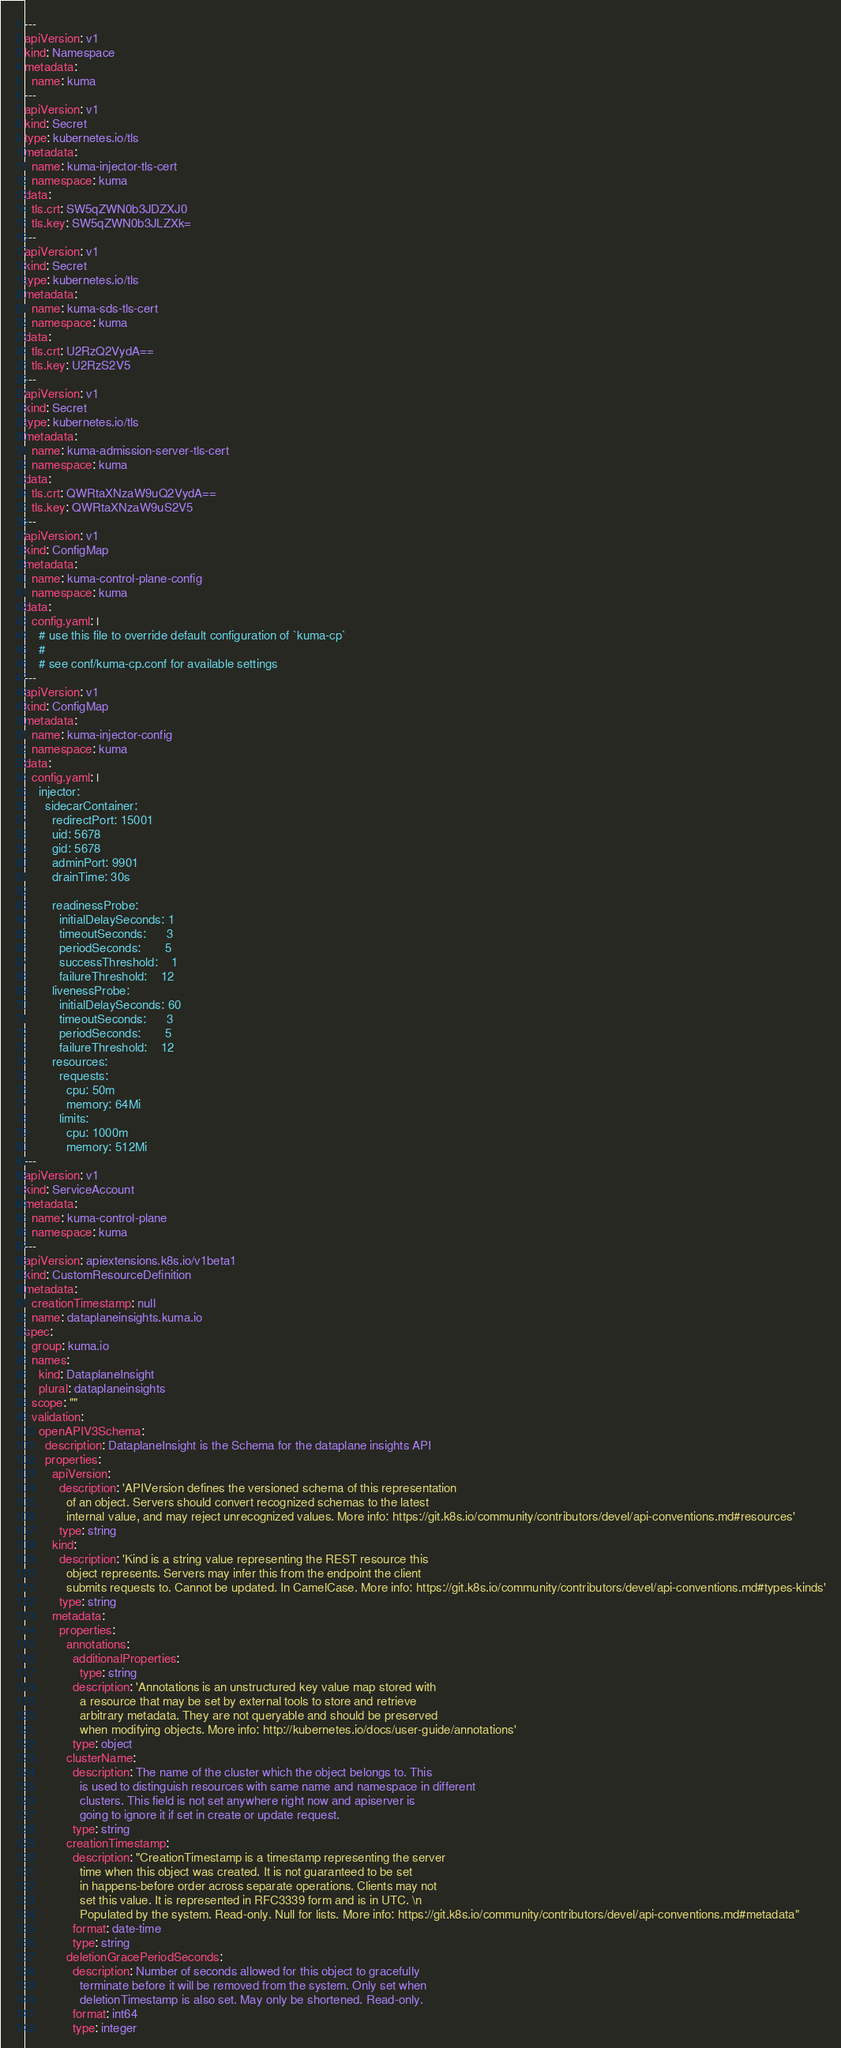Convert code to text. <code><loc_0><loc_0><loc_500><loc_500><_YAML_>---
apiVersion: v1
kind: Namespace
metadata:
  name: kuma
---
apiVersion: v1
kind: Secret
type: kubernetes.io/tls
metadata:
  name: kuma-injector-tls-cert
  namespace: kuma
data:
  tls.crt: SW5qZWN0b3JDZXJ0
  tls.key: SW5qZWN0b3JLZXk=
---
apiVersion: v1
kind: Secret
type: kubernetes.io/tls
metadata:
  name: kuma-sds-tls-cert
  namespace: kuma
data:
  tls.crt: U2RzQ2VydA==
  tls.key: U2RzS2V5
---
apiVersion: v1
kind: Secret
type: kubernetes.io/tls
metadata:
  name: kuma-admission-server-tls-cert
  namespace: kuma
data:
  tls.crt: QWRtaXNzaW9uQ2VydA==
  tls.key: QWRtaXNzaW9uS2V5
---
apiVersion: v1
kind: ConfigMap
metadata:
  name: kuma-control-plane-config
  namespace: kuma
data:
  config.yaml: |
    # use this file to override default configuration of `kuma-cp`
    #
    # see conf/kuma-cp.conf for available settings
---
apiVersion: v1
kind: ConfigMap
metadata:
  name: kuma-injector-config
  namespace: kuma
data:
  config.yaml: |
    injector:
      sidecarContainer:
        redirectPort: 15001
        uid: 5678
        gid: 5678
        adminPort: 9901
        drainTime: 30s

        readinessProbe:
          initialDelaySeconds: 1
          timeoutSeconds:      3
          periodSeconds:       5
          successThreshold:    1
          failureThreshold:    12
        livenessProbe:
          initialDelaySeconds: 60
          timeoutSeconds:      3
          periodSeconds:       5
          failureThreshold:    12
        resources:
          requests:
            cpu: 50m
            memory: 64Mi
          limits:
            cpu: 1000m
            memory: 512Mi
---
apiVersion: v1
kind: ServiceAccount
metadata:
  name: kuma-control-plane
  namespace: kuma
---
apiVersion: apiextensions.k8s.io/v1beta1
kind: CustomResourceDefinition
metadata:
  creationTimestamp: null
  name: dataplaneinsights.kuma.io
spec:
  group: kuma.io
  names:
    kind: DataplaneInsight
    plural: dataplaneinsights
  scope: ""
  validation:
    openAPIV3Schema:
      description: DataplaneInsight is the Schema for the dataplane insights API
      properties:
        apiVersion:
          description: 'APIVersion defines the versioned schema of this representation
            of an object. Servers should convert recognized schemas to the latest
            internal value, and may reject unrecognized values. More info: https://git.k8s.io/community/contributors/devel/api-conventions.md#resources'
          type: string
        kind:
          description: 'Kind is a string value representing the REST resource this
            object represents. Servers may infer this from the endpoint the client
            submits requests to. Cannot be updated. In CamelCase. More info: https://git.k8s.io/community/contributors/devel/api-conventions.md#types-kinds'
          type: string
        metadata:
          properties:
            annotations:
              additionalProperties:
                type: string
              description: 'Annotations is an unstructured key value map stored with
                a resource that may be set by external tools to store and retrieve
                arbitrary metadata. They are not queryable and should be preserved
                when modifying objects. More info: http://kubernetes.io/docs/user-guide/annotations'
              type: object
            clusterName:
              description: The name of the cluster which the object belongs to. This
                is used to distinguish resources with same name and namespace in different
                clusters. This field is not set anywhere right now and apiserver is
                going to ignore it if set in create or update request.
              type: string
            creationTimestamp:
              description: "CreationTimestamp is a timestamp representing the server
                time when this object was created. It is not guaranteed to be set
                in happens-before order across separate operations. Clients may not
                set this value. It is represented in RFC3339 form and is in UTC. \n
                Populated by the system. Read-only. Null for lists. More info: https://git.k8s.io/community/contributors/devel/api-conventions.md#metadata"
              format: date-time
              type: string
            deletionGracePeriodSeconds:
              description: Number of seconds allowed for this object to gracefully
                terminate before it will be removed from the system. Only set when
                deletionTimestamp is also set. May only be shortened. Read-only.
              format: int64
              type: integer</code> 